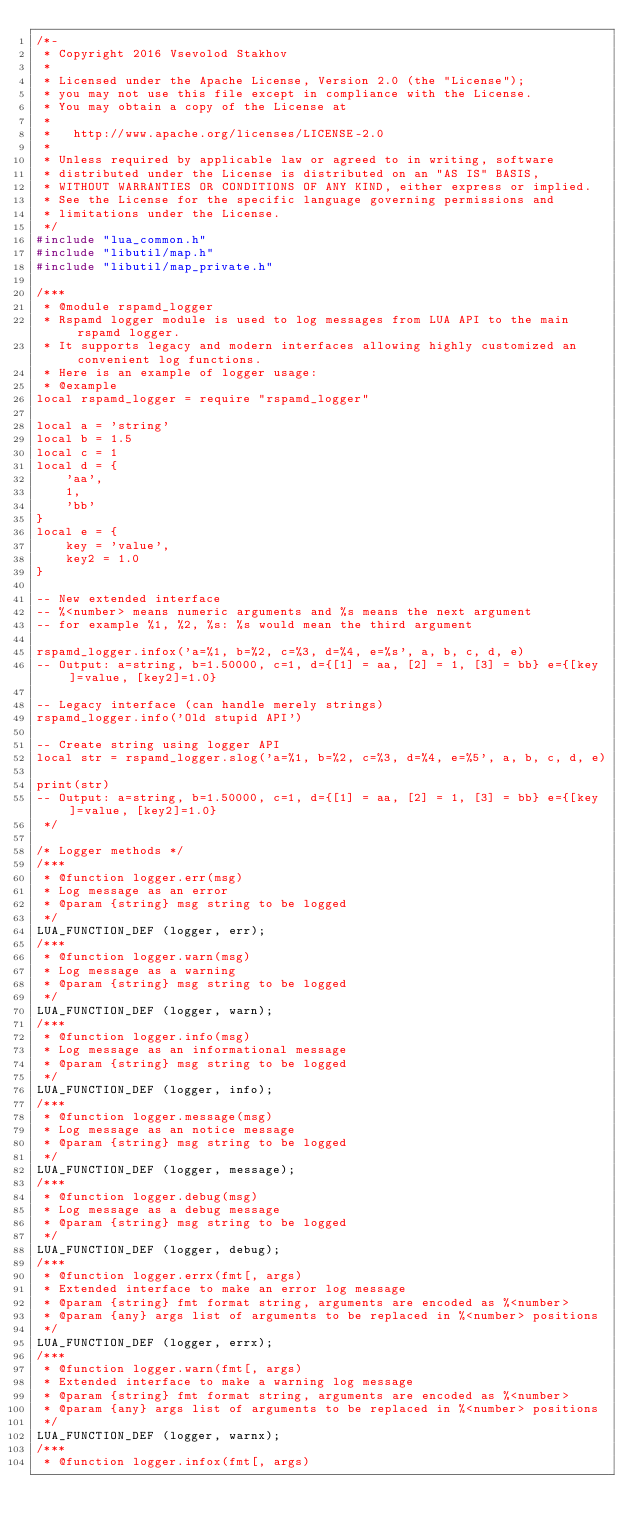<code> <loc_0><loc_0><loc_500><loc_500><_C_>/*-
 * Copyright 2016 Vsevolod Stakhov
 *
 * Licensed under the Apache License, Version 2.0 (the "License");
 * you may not use this file except in compliance with the License.
 * You may obtain a copy of the License at
 *
 *   http://www.apache.org/licenses/LICENSE-2.0
 *
 * Unless required by applicable law or agreed to in writing, software
 * distributed under the License is distributed on an "AS IS" BASIS,
 * WITHOUT WARRANTIES OR CONDITIONS OF ANY KIND, either express or implied.
 * See the License for the specific language governing permissions and
 * limitations under the License.
 */
#include "lua_common.h"
#include "libutil/map.h"
#include "libutil/map_private.h"

/***
 * @module rspamd_logger
 * Rspamd logger module is used to log messages from LUA API to the main rspamd logger.
 * It supports legacy and modern interfaces allowing highly customized an convenient log functions.
 * Here is an example of logger usage:
 * @example
local rspamd_logger = require "rspamd_logger"

local a = 'string'
local b = 1.5
local c = 1
local d = {
	'aa',
	1,
	'bb'
}
local e = {
	key = 'value',
	key2 = 1.0
}

-- New extended interface
-- %<number> means numeric arguments and %s means the next argument
-- for example %1, %2, %s: %s would mean the third argument

rspamd_logger.infox('a=%1, b=%2, c=%3, d=%4, e=%s', a, b, c, d, e)
-- Output: a=string, b=1.50000, c=1, d={[1] = aa, [2] = 1, [3] = bb} e={[key]=value, [key2]=1.0}

-- Legacy interface (can handle merely strings)
rspamd_logger.info('Old stupid API')

-- Create string using logger API
local str = rspamd_logger.slog('a=%1, b=%2, c=%3, d=%4, e=%5', a, b, c, d, e)

print(str)
-- Output: a=string, b=1.50000, c=1, d={[1] = aa, [2] = 1, [3] = bb} e={[key]=value, [key2]=1.0}
 */

/* Logger methods */
/***
 * @function logger.err(msg)
 * Log message as an error
 * @param {string} msg string to be logged
 */
LUA_FUNCTION_DEF (logger, err);
/***
 * @function logger.warn(msg)
 * Log message as a warning
 * @param {string} msg string to be logged
 */
LUA_FUNCTION_DEF (logger, warn);
/***
 * @function logger.info(msg)
 * Log message as an informational message
 * @param {string} msg string to be logged
 */
LUA_FUNCTION_DEF (logger, info);
/***
 * @function logger.message(msg)
 * Log message as an notice message
 * @param {string} msg string to be logged
 */
LUA_FUNCTION_DEF (logger, message);
/***
 * @function logger.debug(msg)
 * Log message as a debug message
 * @param {string} msg string to be logged
 */
LUA_FUNCTION_DEF (logger, debug);
/***
 * @function logger.errx(fmt[, args)
 * Extended interface to make an error log message
 * @param {string} fmt format string, arguments are encoded as %<number>
 * @param {any} args list of arguments to be replaced in %<number> positions
 */
LUA_FUNCTION_DEF (logger, errx);
/***
 * @function logger.warn(fmt[, args)
 * Extended interface to make a warning log message
 * @param {string} fmt format string, arguments are encoded as %<number>
 * @param {any} args list of arguments to be replaced in %<number> positions
 */
LUA_FUNCTION_DEF (logger, warnx);
/***
 * @function logger.infox(fmt[, args)</code> 